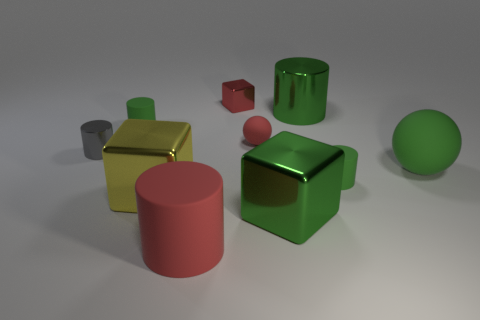How many green cylinders must be subtracted to get 1 green cylinders? 2 Subtract all purple spheres. How many green cylinders are left? 3 Subtract all large metal cylinders. How many cylinders are left? 4 Subtract all red cylinders. How many cylinders are left? 4 Subtract all cyan cylinders. Subtract all green cubes. How many cylinders are left? 5 Subtract all cubes. How many objects are left? 7 Add 4 large green cylinders. How many large green cylinders are left? 5 Add 4 cyan rubber blocks. How many cyan rubber blocks exist? 4 Subtract 0 blue cubes. How many objects are left? 10 Subtract all green metallic cylinders. Subtract all tiny objects. How many objects are left? 4 